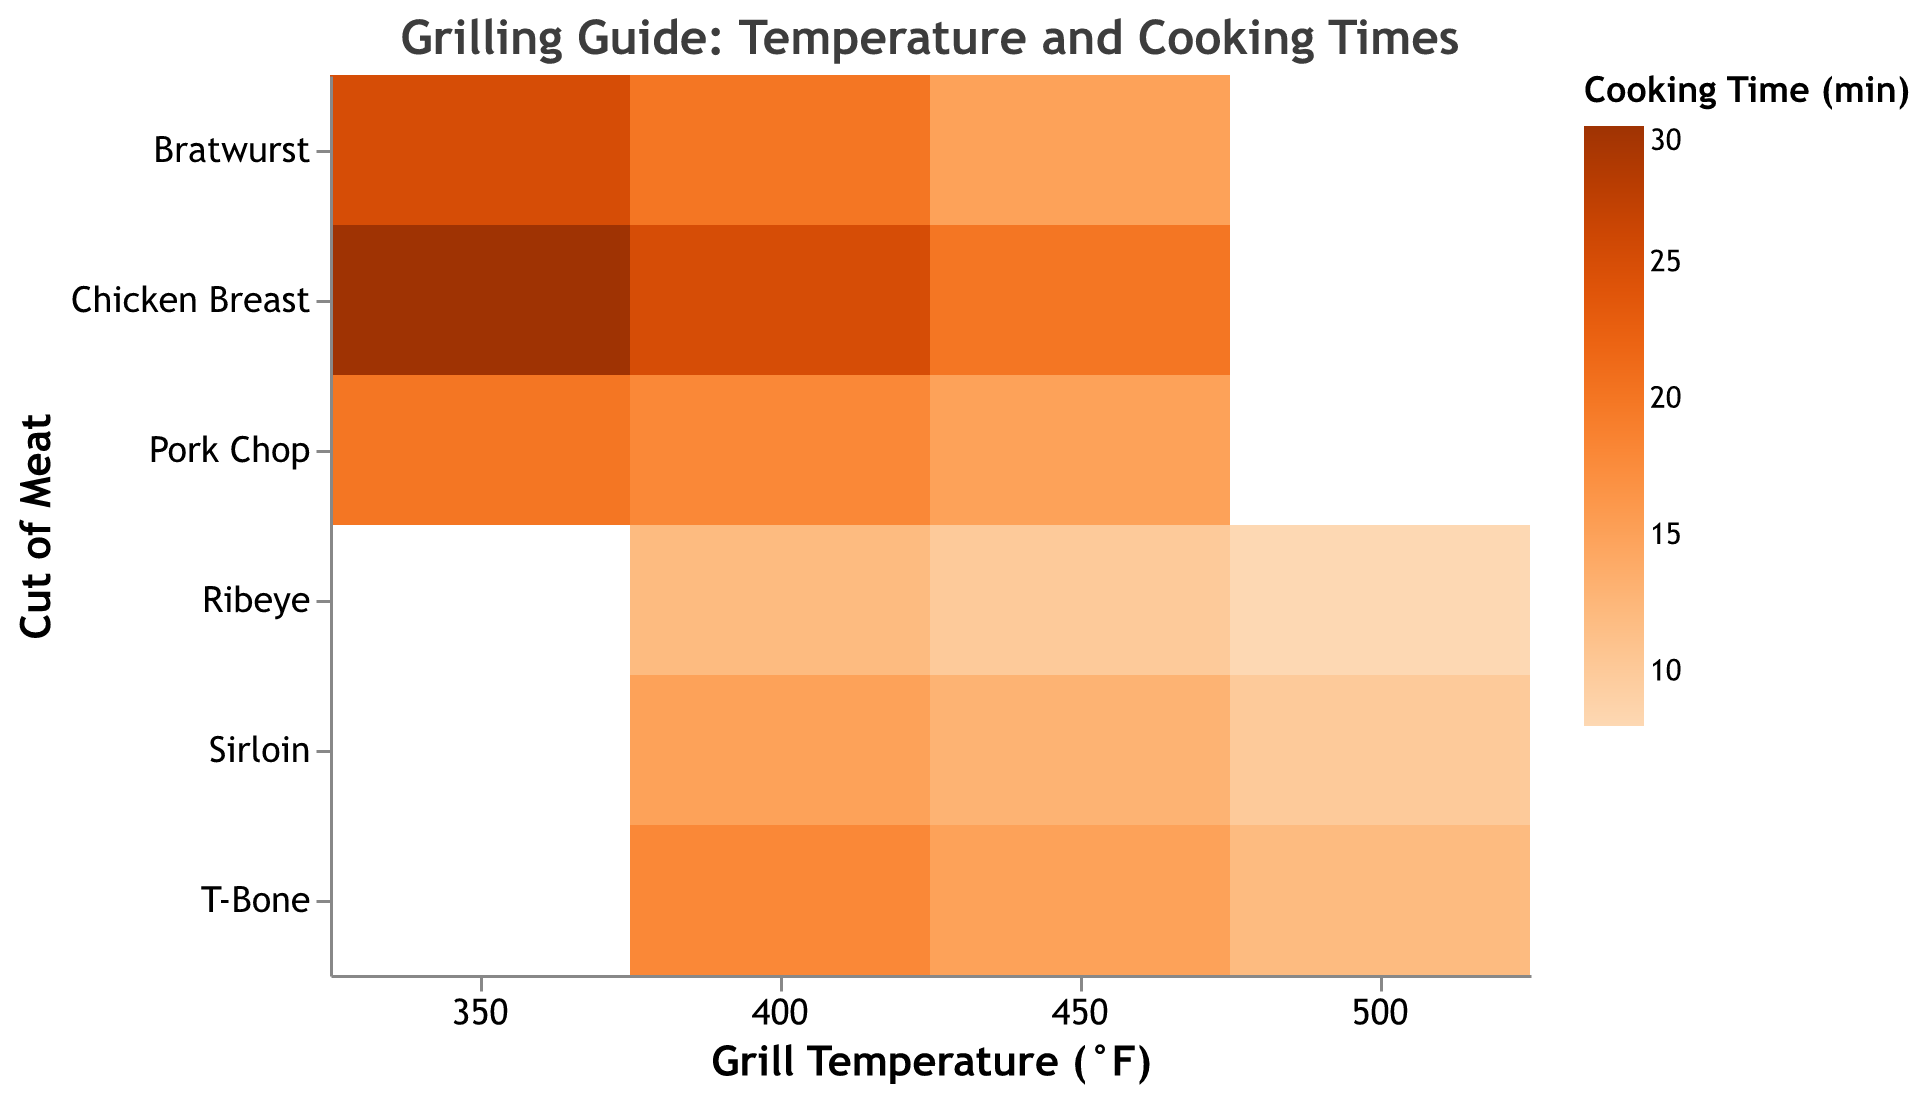What is the title of the heatmap? To identify the title, look at the top of the figure. Titles are typically in larger and bold text. The title is used to explain what the figure is about.
Answer: Grilling Guide: Temperature and Cooking Times Which cut of meat requires the longest cooking time? To find the cut with the longest cooking time, scan the color scale and look for the darkest shade. Then, identify the corresponding cut of meat on the y-axis.
Answer: Chicken Breast How does the cooking time for T-Bone change with temperature? To analyze this, examine the row corresponding to T-Bone across different temperatures on the x-axis. Note how the color changes, indicating the cooking time. As temperature increases, check whether the color gets lighter or darker.
Answer: The cooking time decreases At 400°F, which cut of meat has the shortest cooking time? To find the answer, focus on the column for 400°F. Identify the square with the lightest color, which represents the shortest cooking time. Find the corresponding cut of meat on the y-axis.
Answer: Ribeye What is the cooking time for Pork Chop at 350°F? Locate the 350°F column on the x-axis, then move down to the row for Pork Chop. Check the color in that cell and refer to the legend to get the exact cooking time.
Answer: 20 minutes Which cut of meat has the greatest range of cooking times across different temperatures? To determine this, observe each cut of meat across the three temperatures. Calculate the difference between the highest and lowest cooking times for each cut, and identify the one with the largest range.
Answer: Chicken Breast Compare the cooking times for Bratwurst and Pork Chop at 450°F. Which one cooks faster? To compare, look at the 450°F column and find the rows for Bratwurst and Pork Chop. Identify which cell has a lighter color, indicating a shorter cooking time.
Answer: Pork Chop What temperature provides the shortest cooking time for Sirloin? Focus on the row for Sirloin and identify the cell with the lightest color. Check the corresponding temperature on the x-axis.
Answer: 500°F At what temperature does Chicken Breast require 25 minutes to cook? Locate the row for Chicken Breast and find the cell that corresponds to 25 minutes by matching the color to the legend. Check the corresponding temperature on the x-axis.
Answer: 400°F Is the cooking time for Ribeye always shorter than for Sirloin at any given temperature? Compare the cooking times for Ribeye and Sirloin at 400°F, 450°F, and 500°F by looking at the colors in their respective rows. Determine if Ribeye's times are always shorter (lighter colors).
Answer: Yes 